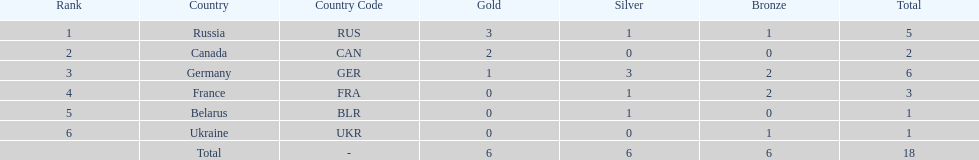Name the country that had the same number of bronze medals as russia. Ukraine. 